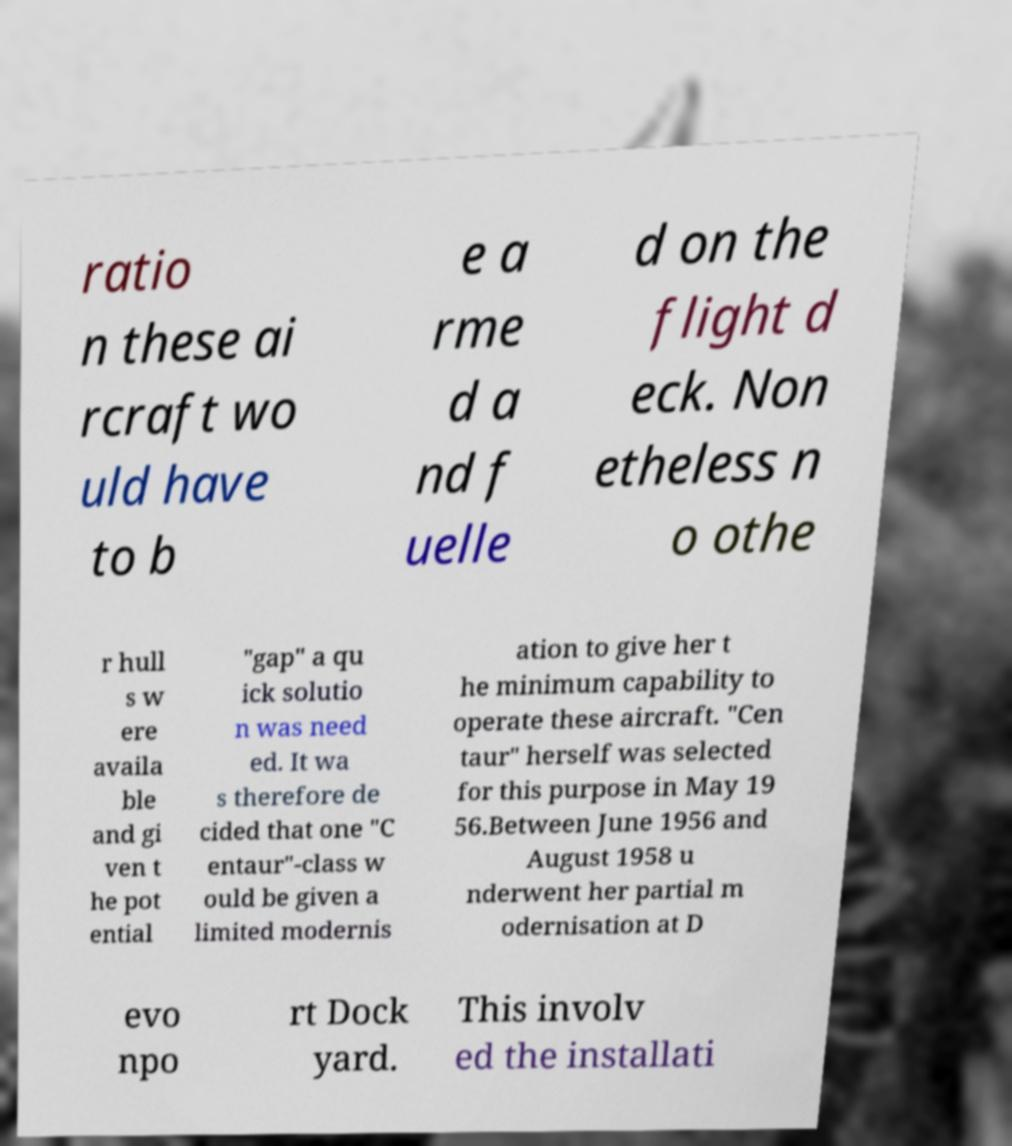Please identify and transcribe the text found in this image. ratio n these ai rcraft wo uld have to b e a rme d a nd f uelle d on the flight d eck. Non etheless n o othe r hull s w ere availa ble and gi ven t he pot ential "gap" a qu ick solutio n was need ed. It wa s therefore de cided that one "C entaur"-class w ould be given a limited modernis ation to give her t he minimum capability to operate these aircraft. "Cen taur" herself was selected for this purpose in May 19 56.Between June 1956 and August 1958 u nderwent her partial m odernisation at D evo npo rt Dock yard. This involv ed the installati 